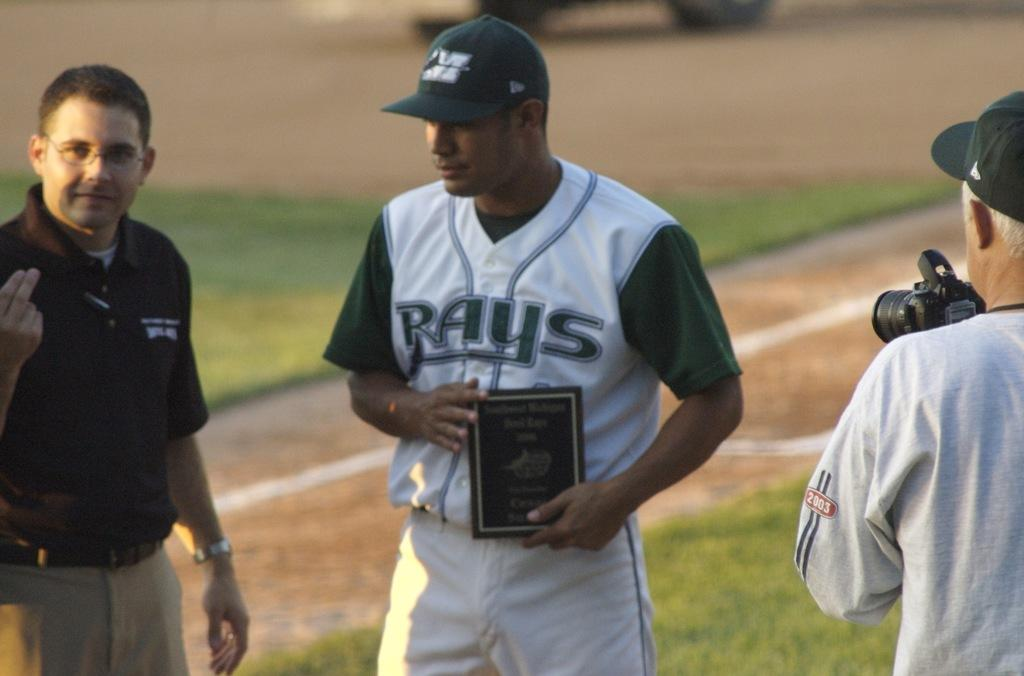<image>
Describe the image concisely. the team name Rays is on the jersey of a person 